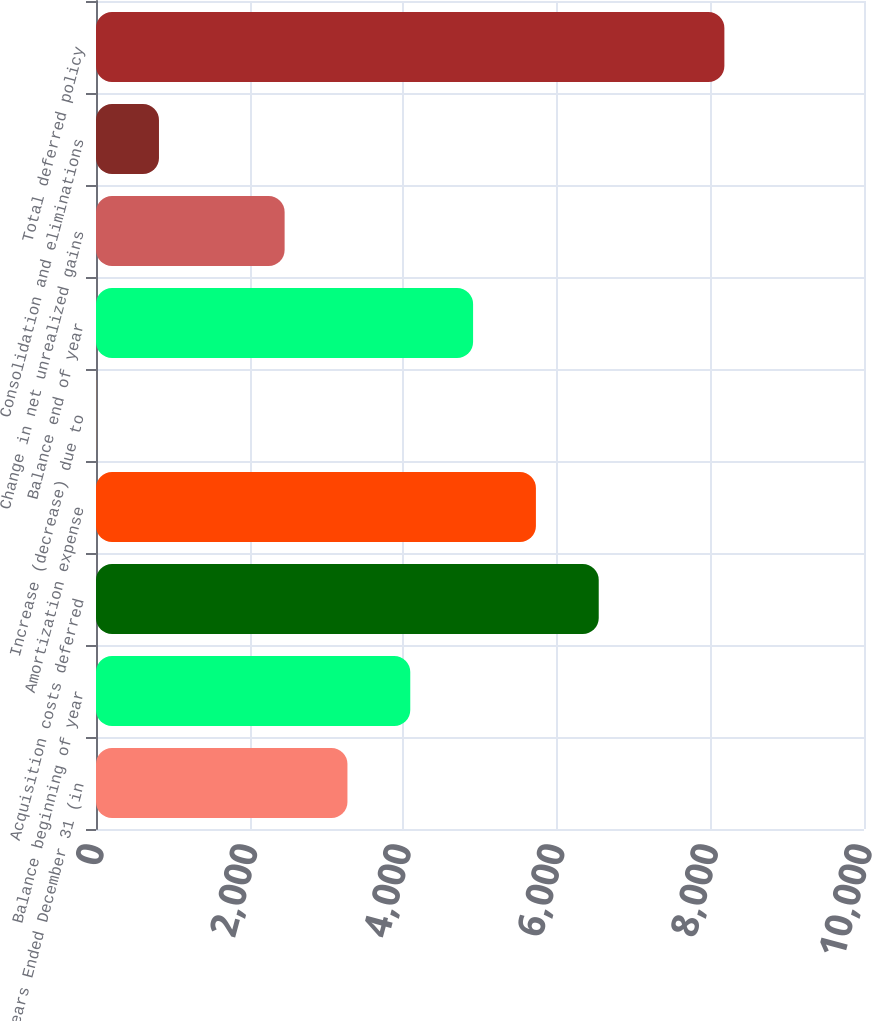<chart> <loc_0><loc_0><loc_500><loc_500><bar_chart><fcel>Years Ended December 31 (in<fcel>Balance beginning of year<fcel>Acquisition costs deferred<fcel>Amortization expense<fcel>Increase (decrease) due to<fcel>Balance end of year<fcel>Change in net unrealized gains<fcel>Consolidation and eliminations<fcel>Total deferred policy<nl><fcel>3274<fcel>4092<fcel>6546<fcel>5728<fcel>2<fcel>4910<fcel>2456<fcel>820<fcel>8182<nl></chart> 